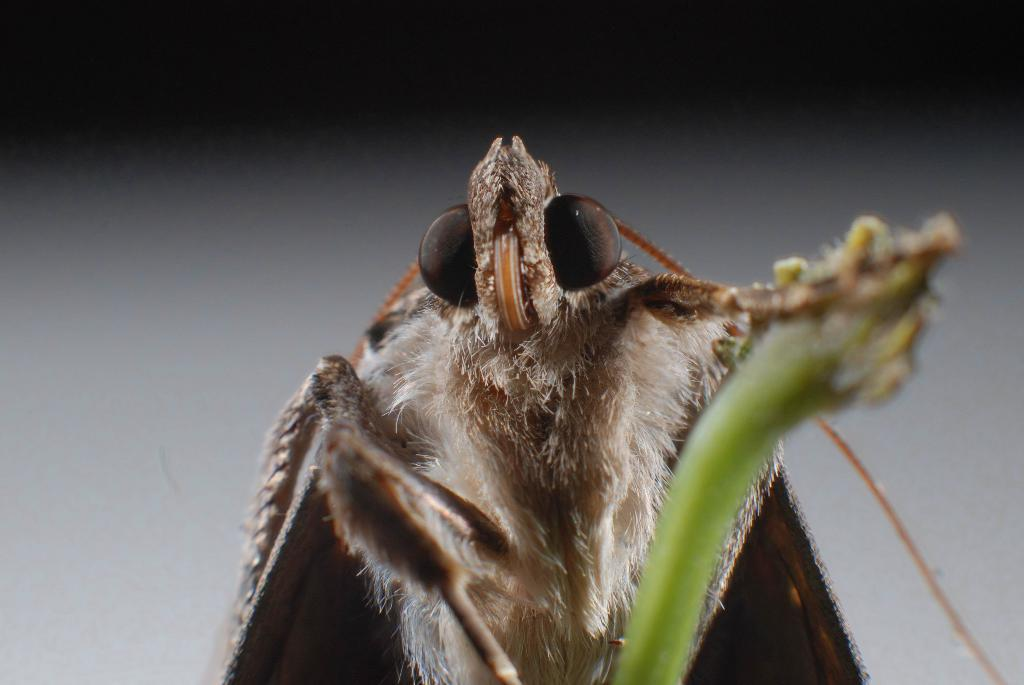What type of creature can be seen in the image? There is an insect in the image. What type of tin is the insect using to communicate with its father and grandfather? There is no tin or communication with a father or grandfather present in the image; it only features an insect. 